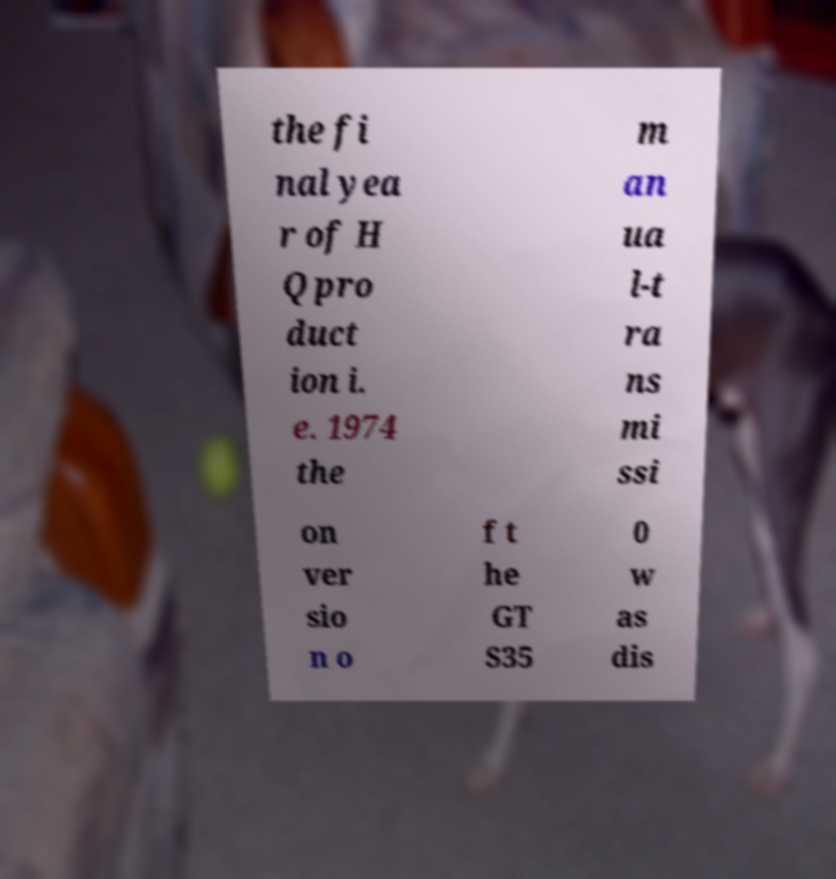For documentation purposes, I need the text within this image transcribed. Could you provide that? the fi nal yea r of H Q pro duct ion i. e. 1974 the m an ua l-t ra ns mi ssi on ver sio n o f t he GT S35 0 w as dis 